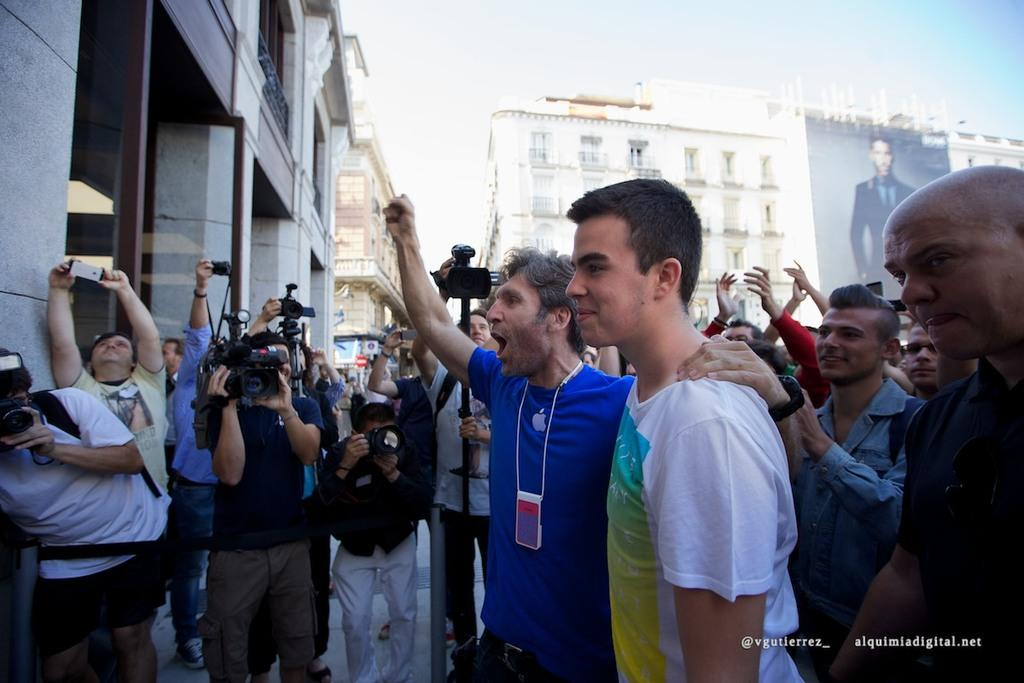What is the main subject of the image? The main subject of the image is a group of people in front of a building. What are some people doing in the image? Some people are holding cameras in the image. What can be seen in the background of the image? There are buildings in the background of the image. What additional detail can be observed in the image? There is a banner visible in the image. What type of wren can be seen perched on the banner in the image? There is no wren present in the image; it is a group of people in front of a building with a banner. What type of education is being promoted on the banner in the image? There is no information about education on the banner in the image; it only displays a message or advertisement. 